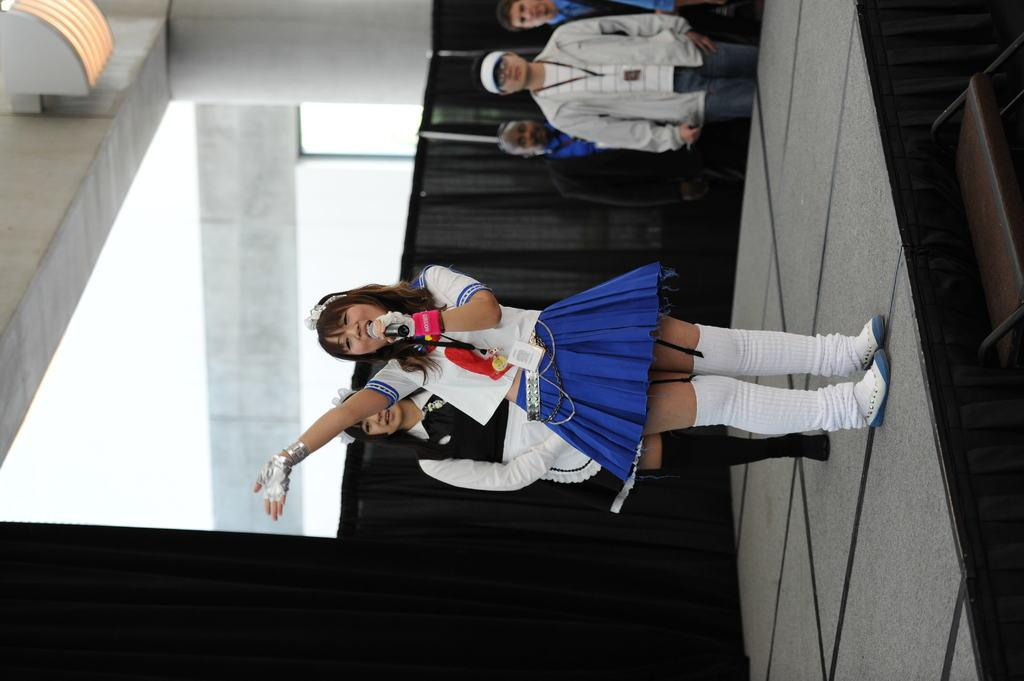What is present in the background of the image? There is a wall in the image. Can you describe the people in the image? There are people standing in the image. What can be seen in the sky in the image? The sky is visible in the image. What is the woman wearing in the image? The woman is wearing a blue t-shirt and white shoes in the image. What is the woman holding in the image? The woman is holding a mic in the image. What type of chair is the woman sitting on in the image? There is no chair present in the image; the woman is standing. What shape is the leather object in the image? There is no leather object present in the image. 